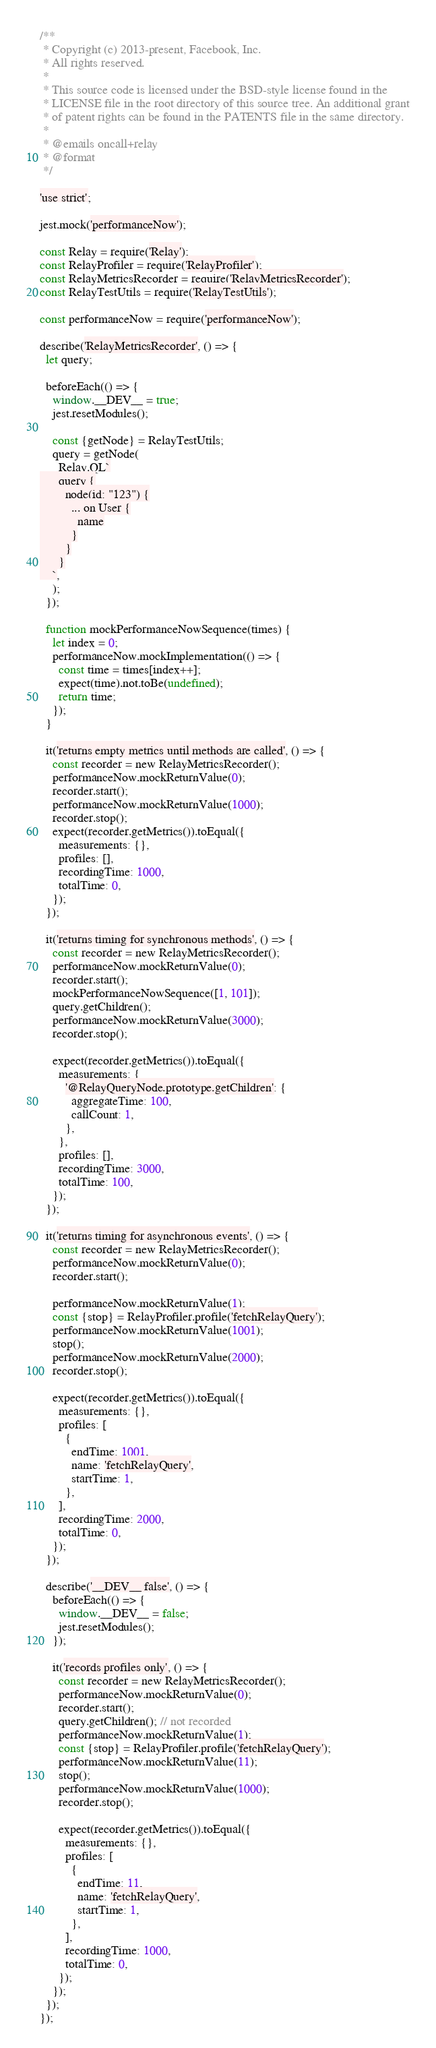Convert code to text. <code><loc_0><loc_0><loc_500><loc_500><_JavaScript_>/**
 * Copyright (c) 2013-present, Facebook, Inc.
 * All rights reserved.
 *
 * This source code is licensed under the BSD-style license found in the
 * LICENSE file in the root directory of this source tree. An additional grant
 * of patent rights can be found in the PATENTS file in the same directory.
 *
 * @emails oncall+relay
 * @format
 */

'use strict';

jest.mock('performanceNow');

const Relay = require('Relay');
const RelayProfiler = require('RelayProfiler');
const RelayMetricsRecorder = require('RelayMetricsRecorder');
const RelayTestUtils = require('RelayTestUtils');

const performanceNow = require('performanceNow');

describe('RelayMetricsRecorder', () => {
  let query;

  beforeEach(() => {
    window.__DEV__ = true;
    jest.resetModules();

    const {getNode} = RelayTestUtils;
    query = getNode(
      Relay.QL`
      query {
        node(id: "123") {
          ... on User {
            name
          }
        }
      }
    `,
    );
  });

  function mockPerformanceNowSequence(times) {
    let index = 0;
    performanceNow.mockImplementation(() => {
      const time = times[index++];
      expect(time).not.toBe(undefined);
      return time;
    });
  }

  it('returns empty metrics until methods are called', () => {
    const recorder = new RelayMetricsRecorder();
    performanceNow.mockReturnValue(0);
    recorder.start();
    performanceNow.mockReturnValue(1000);
    recorder.stop();
    expect(recorder.getMetrics()).toEqual({
      measurements: {},
      profiles: [],
      recordingTime: 1000,
      totalTime: 0,
    });
  });

  it('returns timing for synchronous methods', () => {
    const recorder = new RelayMetricsRecorder();
    performanceNow.mockReturnValue(0);
    recorder.start();
    mockPerformanceNowSequence([1, 101]);
    query.getChildren();
    performanceNow.mockReturnValue(3000);
    recorder.stop();

    expect(recorder.getMetrics()).toEqual({
      measurements: {
        '@RelayQueryNode.prototype.getChildren': {
          aggregateTime: 100,
          callCount: 1,
        },
      },
      profiles: [],
      recordingTime: 3000,
      totalTime: 100,
    });
  });

  it('returns timing for asynchronous events', () => {
    const recorder = new RelayMetricsRecorder();
    performanceNow.mockReturnValue(0);
    recorder.start();

    performanceNow.mockReturnValue(1);
    const {stop} = RelayProfiler.profile('fetchRelayQuery');
    performanceNow.mockReturnValue(1001);
    stop();
    performanceNow.mockReturnValue(2000);
    recorder.stop();

    expect(recorder.getMetrics()).toEqual({
      measurements: {},
      profiles: [
        {
          endTime: 1001,
          name: 'fetchRelayQuery',
          startTime: 1,
        },
      ],
      recordingTime: 2000,
      totalTime: 0,
    });
  });

  describe('__DEV__ false', () => {
    beforeEach(() => {
      window.__DEV__ = false;
      jest.resetModules();
    });

    it('records profiles only', () => {
      const recorder = new RelayMetricsRecorder();
      performanceNow.mockReturnValue(0);
      recorder.start();
      query.getChildren(); // not recorded
      performanceNow.mockReturnValue(1);
      const {stop} = RelayProfiler.profile('fetchRelayQuery');
      performanceNow.mockReturnValue(11);
      stop();
      performanceNow.mockReturnValue(1000);
      recorder.stop();

      expect(recorder.getMetrics()).toEqual({
        measurements: {},
        profiles: [
          {
            endTime: 11,
            name: 'fetchRelayQuery',
            startTime: 1,
          },
        ],
        recordingTime: 1000,
        totalTime: 0,
      });
    });
  });
});
</code> 